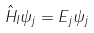Convert formula to latex. <formula><loc_0><loc_0><loc_500><loc_500>\hat { H } _ { I } \psi _ { j } = E _ { j } \psi _ { j }</formula> 